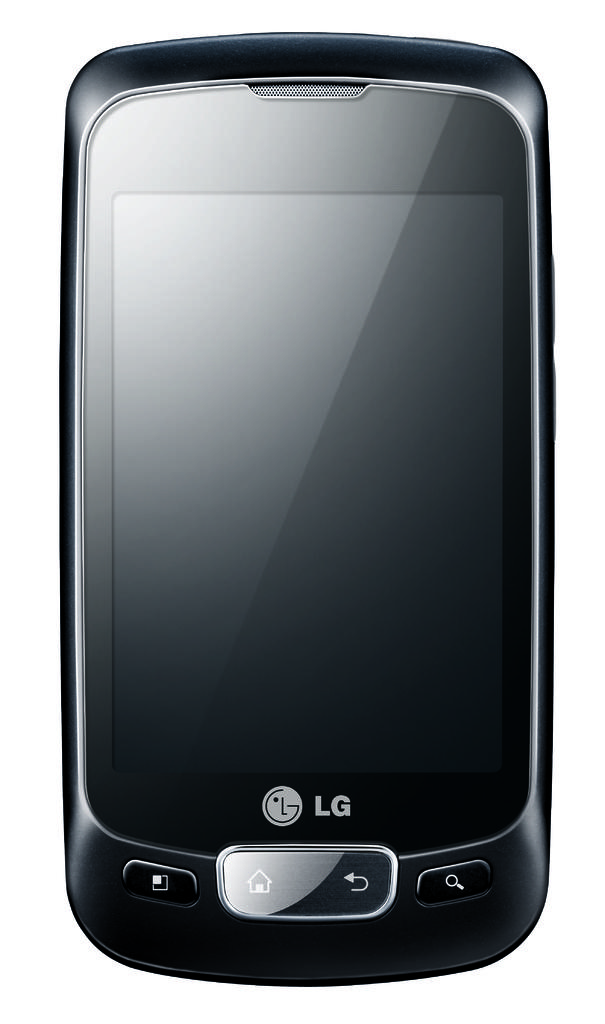What type of phone is this?
Provide a short and direct response. Lg. 